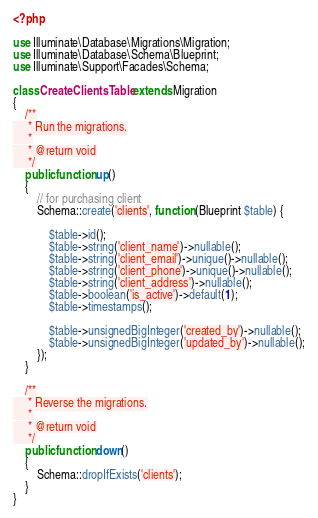Convert code to text. <code><loc_0><loc_0><loc_500><loc_500><_PHP_><?php

use Illuminate\Database\Migrations\Migration;
use Illuminate\Database\Schema\Blueprint;
use Illuminate\Support\Facades\Schema;

class CreateClientsTable extends Migration
{
    /**
     * Run the migrations.
     *
     * @return void
     */
    public function up()
    {
        // for purchasing client
        Schema::create('clients', function (Blueprint $table) {
            
            $table->id();
            $table->string('client_name')->nullable();
            $table->string('client_email')->unique()->nullable();
            $table->string('client_phone')->unique()->nullable();
            $table->string('client_address')->nullable();
            $table->boolean('is_active')->default(1);
            $table->timestamps();

            $table->unsignedBigInteger('created_by')->nullable();
            $table->unsignedBigInteger('updated_by')->nullable();
        });
    }

    /**
     * Reverse the migrations.
     *
     * @return void
     */
    public function down()
    {
        Schema::dropIfExists('clients');
    }
}
</code> 